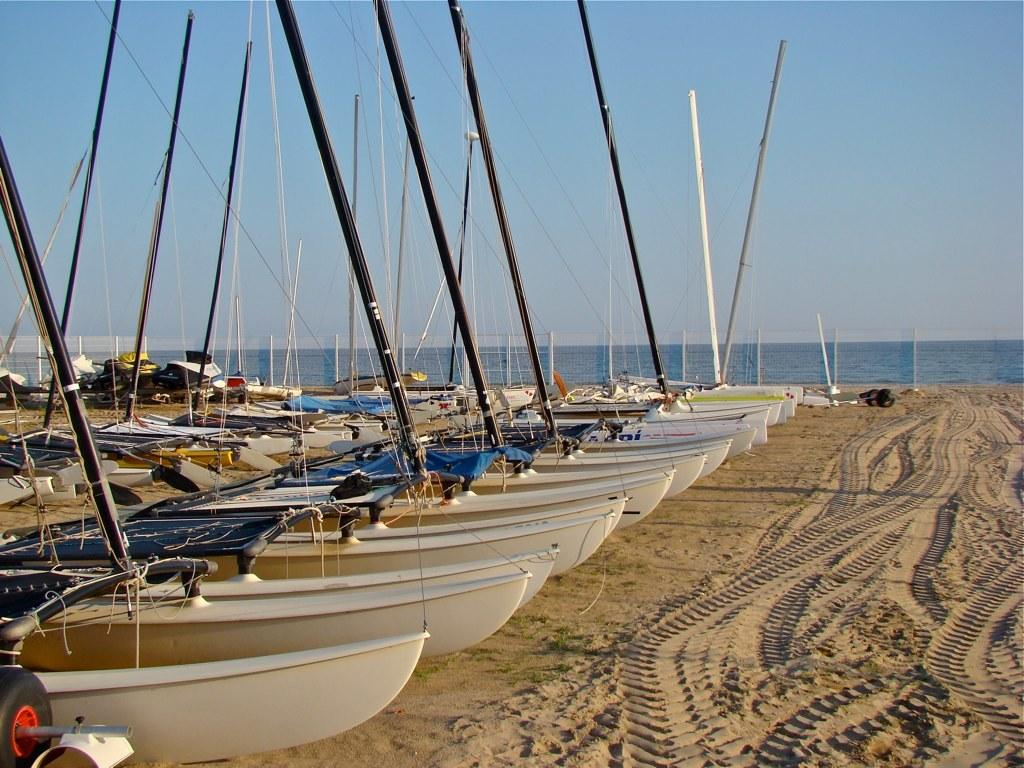What can be seen on the left side of the image? There are boats on the left side of the image. What type of terrain is visible in the image? There is sand visible in the image. What is the background of the image? There is an ocean in the background of the image. How would you describe the weather in the image? The sky is clear in the image, suggesting good weather. Where is the lettuce growing in the image? There is no lettuce present in the image. What type of competition is taking place in the image? There is no competition depicted in the image. Can you tell me where the mailbox is located in the image? There is no mailbox present in the image. 